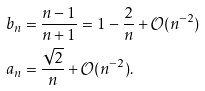<formula> <loc_0><loc_0><loc_500><loc_500>b _ { n } & = \frac { n - 1 } { n + 1 } = 1 - \frac { 2 } { n } + \mathcal { O } ( n ^ { - 2 } ) \\ a _ { n } & = \frac { \sqrt { 2 } } { n } + \mathcal { O } ( n ^ { - 2 } ) .</formula> 